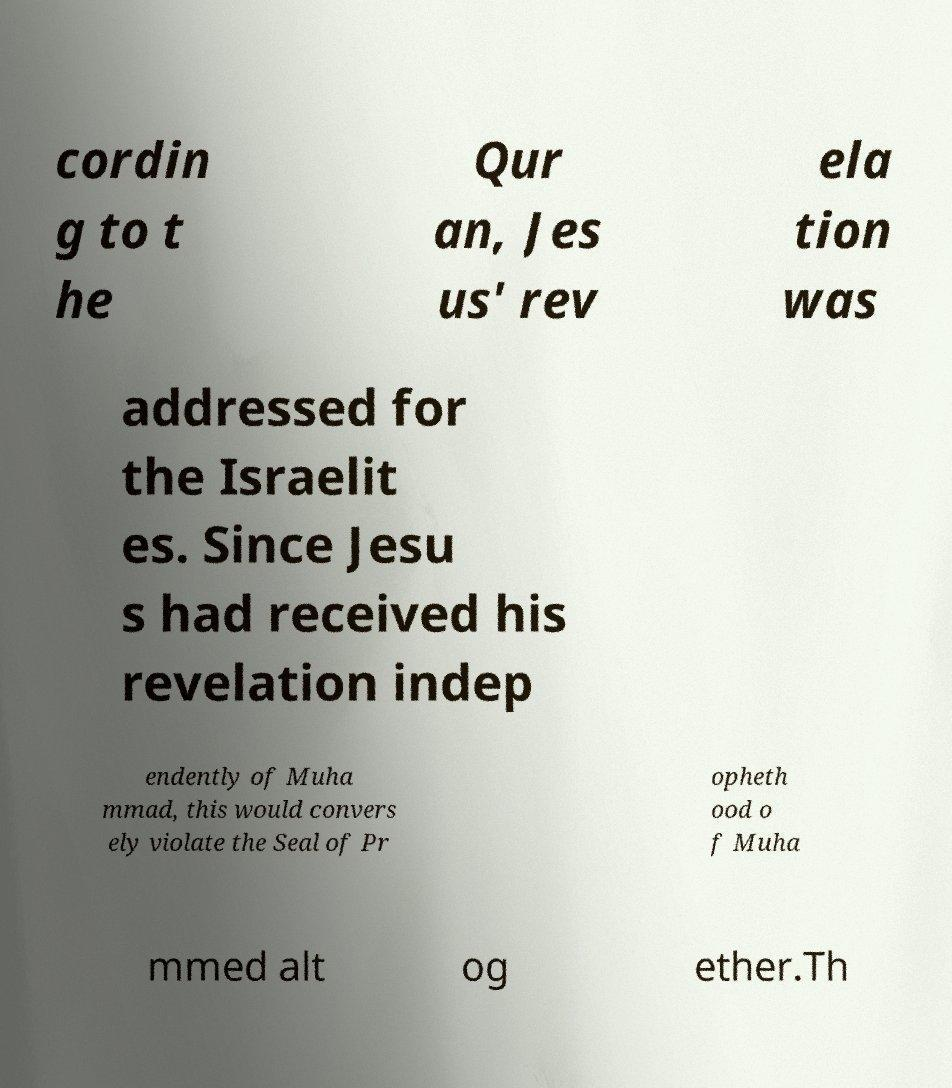Please identify and transcribe the text found in this image. cordin g to t he Qur an, Jes us' rev ela tion was addressed for the Israelit es. Since Jesu s had received his revelation indep endently of Muha mmad, this would convers ely violate the Seal of Pr opheth ood o f Muha mmed alt og ether.Th 